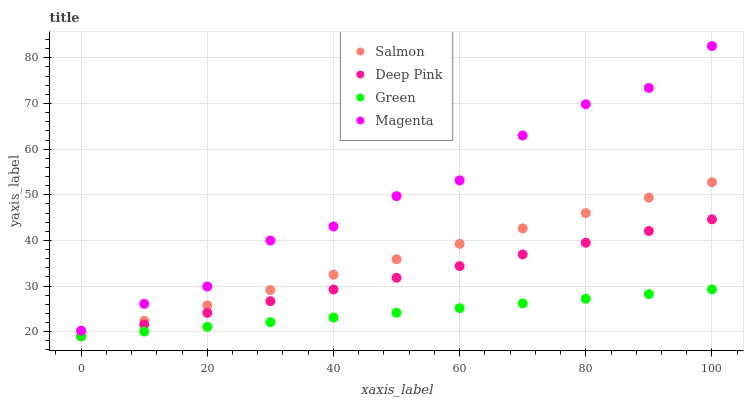Does Green have the minimum area under the curve?
Answer yes or no. Yes. Does Magenta have the maximum area under the curve?
Answer yes or no. Yes. Does Deep Pink have the minimum area under the curve?
Answer yes or no. No. Does Deep Pink have the maximum area under the curve?
Answer yes or no. No. Is Green the smoothest?
Answer yes or no. Yes. Is Magenta the roughest?
Answer yes or no. Yes. Is Deep Pink the smoothest?
Answer yes or no. No. Is Deep Pink the roughest?
Answer yes or no. No. Does Green have the lowest value?
Answer yes or no. Yes. Does Magenta have the lowest value?
Answer yes or no. No. Does Magenta have the highest value?
Answer yes or no. Yes. Does Deep Pink have the highest value?
Answer yes or no. No. Is Green less than Magenta?
Answer yes or no. Yes. Is Magenta greater than Green?
Answer yes or no. Yes. Does Deep Pink intersect Salmon?
Answer yes or no. Yes. Is Deep Pink less than Salmon?
Answer yes or no. No. Is Deep Pink greater than Salmon?
Answer yes or no. No. Does Green intersect Magenta?
Answer yes or no. No. 